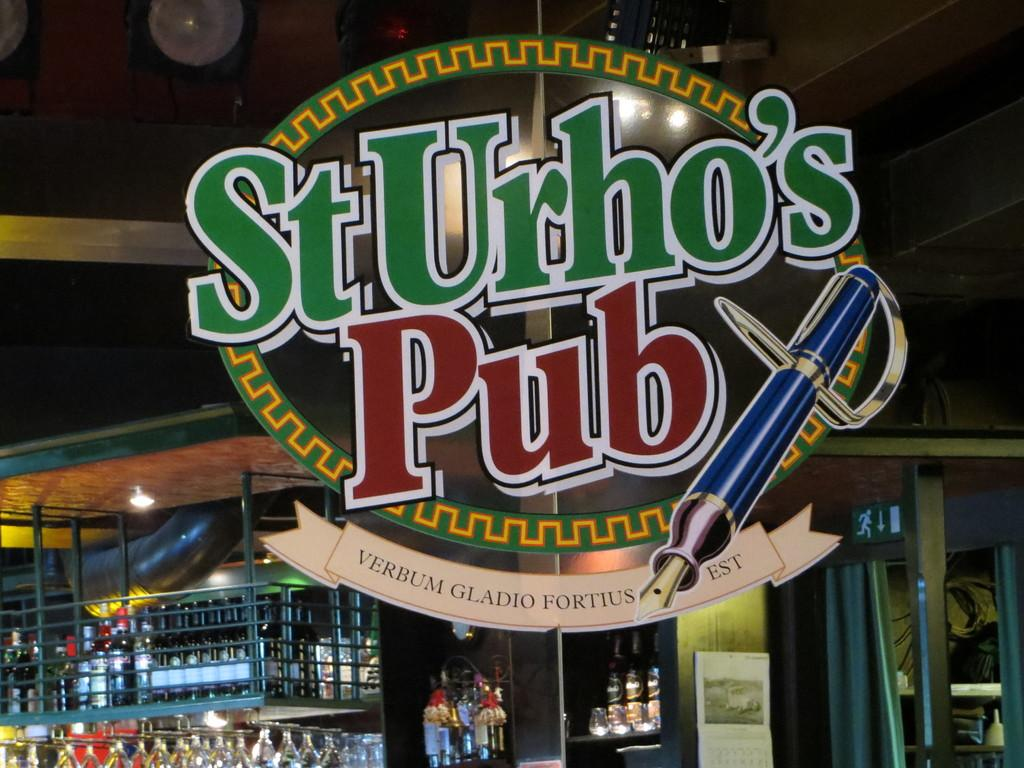What is the main object in the image that indicates the location? There is a name board in the image, which represents an inner view of a pub. What type of beverages can be seen in the image? There are bottles and wine glasses in the image. What type of lighting is present in the image? There are lights on the roof in the image. What type of window treatment is present in the image? There is a curtain in the image. What other signage is present in the image? There is a sign board in the image. How does the sleet affect the outdoor seating area in the image? There is no outdoor seating area visible in the image, so it is not possible to determine the effect of sleet. What type of care is provided to the customers in the image? The image does not show any interaction between customers and staff, so it is not possible to determine the type of care provided. 